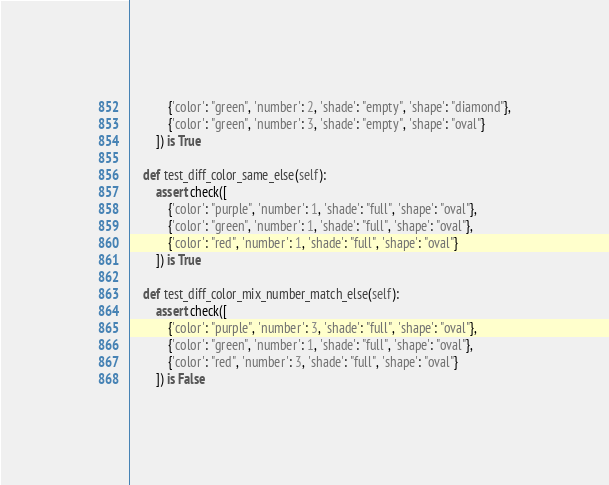Convert code to text. <code><loc_0><loc_0><loc_500><loc_500><_Python_>            {'color': "green", 'number': 2, 'shade': "empty", 'shape': "diamond"},
            {'color': "green", 'number': 3, 'shade': "empty", 'shape': "oval"}
        ]) is True

    def test_diff_color_same_else(self):
        assert check([
            {'color': "purple", 'number': 1, 'shade': "full", 'shape': "oval"},
            {'color': "green", 'number': 1, 'shade': "full", 'shape': "oval"},
            {'color': "red", 'number': 1, 'shade': "full", 'shape': "oval"}
        ]) is True

    def test_diff_color_mix_number_match_else(self):
        assert check([
            {'color': "purple", 'number': 3, 'shade': "full", 'shape': "oval"},
            {'color': "green", 'number': 1, 'shade': "full", 'shape': "oval"},
            {'color': "red", 'number': 3, 'shade': "full", 'shape': "oval"}
        ]) is False
</code> 